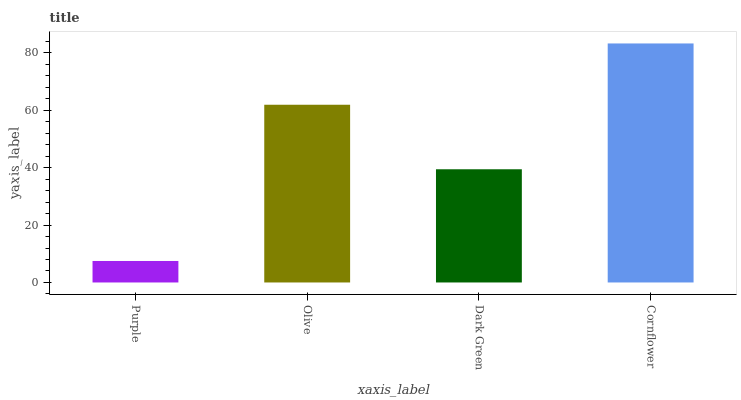Is Olive the minimum?
Answer yes or no. No. Is Olive the maximum?
Answer yes or no. No. Is Olive greater than Purple?
Answer yes or no. Yes. Is Purple less than Olive?
Answer yes or no. Yes. Is Purple greater than Olive?
Answer yes or no. No. Is Olive less than Purple?
Answer yes or no. No. Is Olive the high median?
Answer yes or no. Yes. Is Dark Green the low median?
Answer yes or no. Yes. Is Dark Green the high median?
Answer yes or no. No. Is Cornflower the low median?
Answer yes or no. No. 